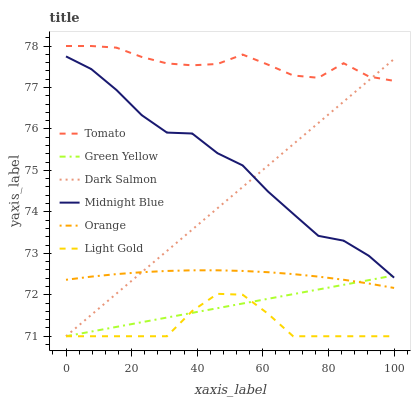Does Light Gold have the minimum area under the curve?
Answer yes or no. Yes. Does Tomato have the maximum area under the curve?
Answer yes or no. Yes. Does Midnight Blue have the minimum area under the curve?
Answer yes or no. No. Does Midnight Blue have the maximum area under the curve?
Answer yes or no. No. Is Dark Salmon the smoothest?
Answer yes or no. Yes. Is Midnight Blue the roughest?
Answer yes or no. Yes. Is Midnight Blue the smoothest?
Answer yes or no. No. Is Dark Salmon the roughest?
Answer yes or no. No. Does Dark Salmon have the lowest value?
Answer yes or no. Yes. Does Midnight Blue have the lowest value?
Answer yes or no. No. Does Tomato have the highest value?
Answer yes or no. Yes. Does Midnight Blue have the highest value?
Answer yes or no. No. Is Light Gold less than Midnight Blue?
Answer yes or no. Yes. Is Tomato greater than Green Yellow?
Answer yes or no. Yes. Does Light Gold intersect Dark Salmon?
Answer yes or no. Yes. Is Light Gold less than Dark Salmon?
Answer yes or no. No. Is Light Gold greater than Dark Salmon?
Answer yes or no. No. Does Light Gold intersect Midnight Blue?
Answer yes or no. No. 